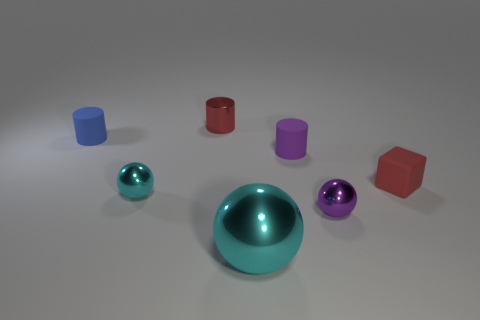How many purple rubber cylinders have the same size as the red metal object? There is one purple rubber cylinder that matches the size of the red metal object. It's fascinating to observe how different materials and colors can have objects of the same dimensions, giving us a sense of variety in a harmonious arrangement. 